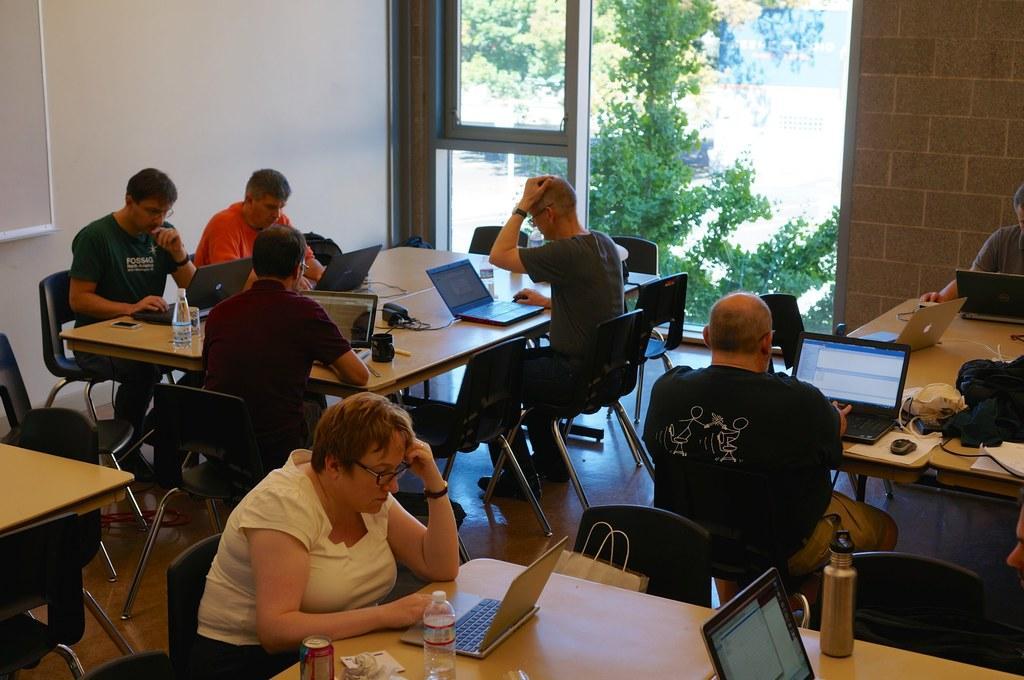In one or two sentences, can you explain what this image depicts? In this picture we can see a group of people sitting on chair and working on laptops and in front of them there is table and on table we can see bottles, papers, cup, devices, glass, laptops and in background we can see wall, window, tree. 